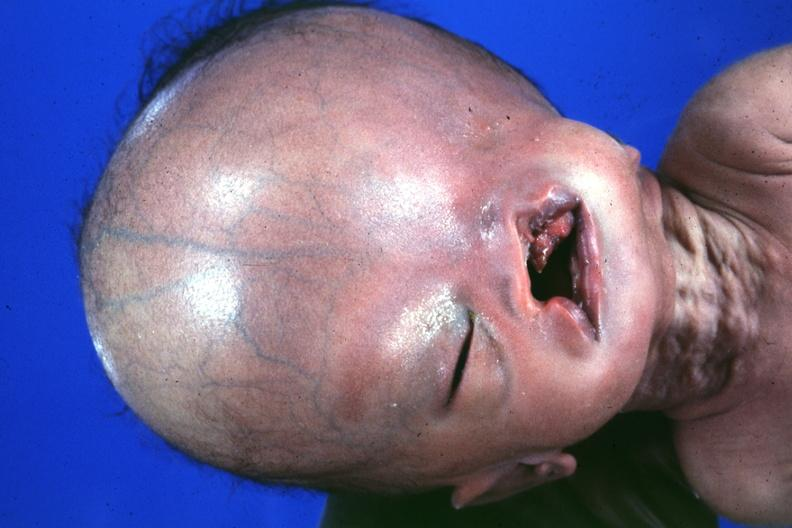what does absence of palpebral fissure cleft palate see?
Answer the question using a single word or phrase. Protocol for details 